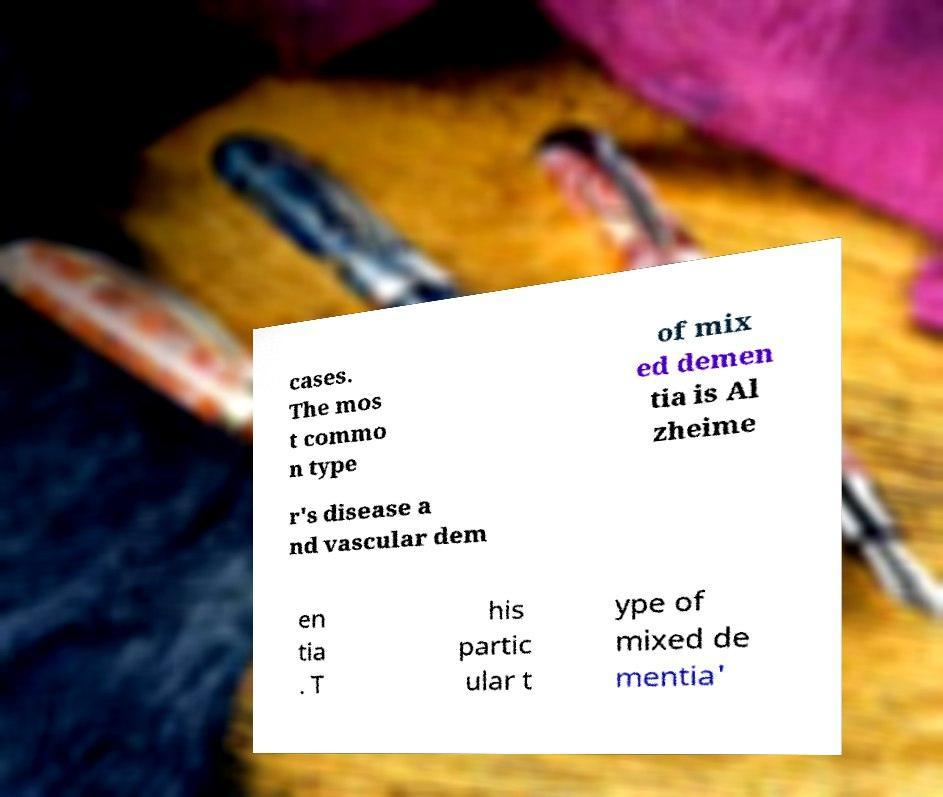Please identify and transcribe the text found in this image. cases. The mos t commo n type of mix ed demen tia is Al zheime r's disease a nd vascular dem en tia . T his partic ular t ype of mixed de mentia' 